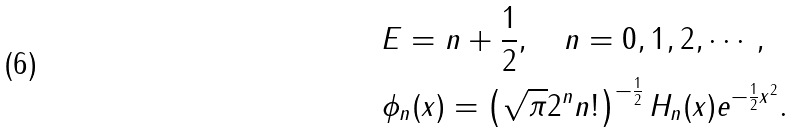Convert formula to latex. <formula><loc_0><loc_0><loc_500><loc_500>& E = n + \frac { 1 } { 2 } , \quad n = 0 , 1 , 2 , \cdots , \\ & \phi _ { n } ( x ) = \left ( \sqrt { \pi } 2 ^ { n } n ! \right ) ^ { - \frac { 1 } { 2 } } H _ { n } ( x ) e ^ { - \frac { 1 } { 2 } x ^ { 2 } } .</formula> 